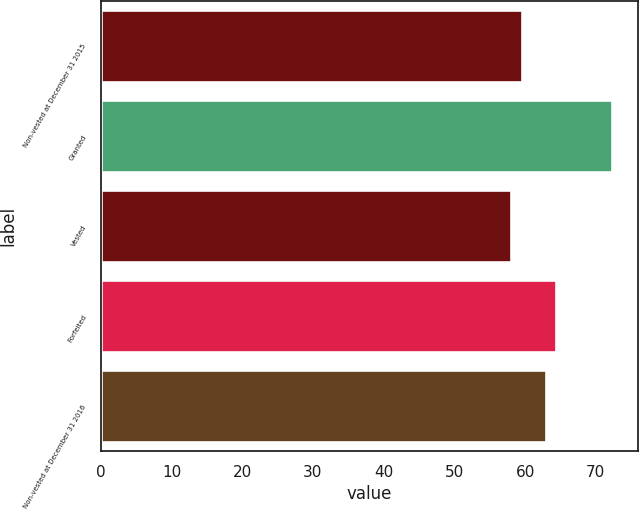Convert chart. <chart><loc_0><loc_0><loc_500><loc_500><bar_chart><fcel>Non-vested at December 31 2015<fcel>Granted<fcel>Vested<fcel>Forfeited<fcel>Non-vested at December 31 2016<nl><fcel>59.5<fcel>72.34<fcel>58.07<fcel>64.43<fcel>63<nl></chart> 